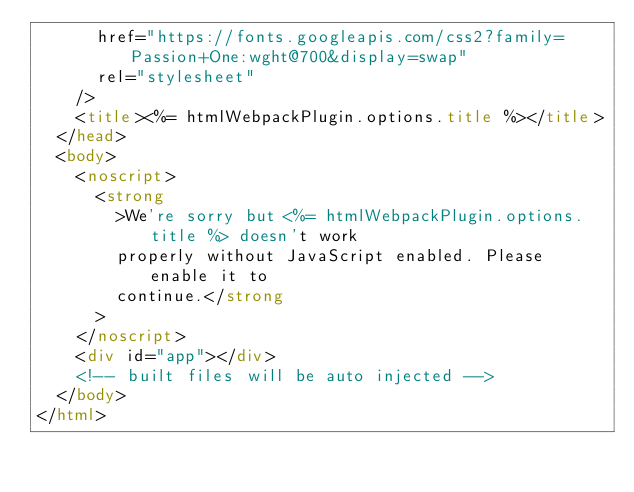<code> <loc_0><loc_0><loc_500><loc_500><_HTML_>      href="https://fonts.googleapis.com/css2?family=Passion+One:wght@700&display=swap"
      rel="stylesheet"
    />
    <title><%= htmlWebpackPlugin.options.title %></title>
  </head>
  <body>
    <noscript>
      <strong
        >We're sorry but <%= htmlWebpackPlugin.options.title %> doesn't work
        properly without JavaScript enabled. Please enable it to
        continue.</strong
      >
    </noscript>
    <div id="app"></div>
    <!-- built files will be auto injected -->
  </body>
</html>
</code> 